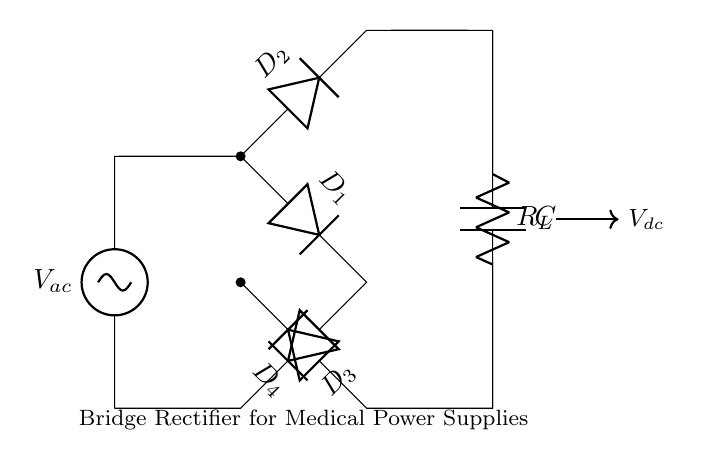What is the input voltage type in this circuit? The input voltage type is alternating current, indicated by the designation "V_ac" in the circuit.
Answer: alternating current How many diodes are used in this bridge rectifier? There are four diodes used in this bridge rectifier, specifically labeled D_1, D_2, D_3, and D_4.
Answer: four What does the capacitor (C) do in this circuit? The capacitor smooths the output voltage by filtering the rectified signal, helping to stabilize the voltage for the load.
Answer: stabilize voltage What is the purpose of the resistor (R_L) in this circuit? The resistor R_L acts as a load to draw current from the output of the rectifier, simulating the device's power demand.
Answer: load What type of circuit is represented here? This is a bridge rectifier circuit, as evidenced by the arrangement of four diodes forming a bridge configuration.
Answer: bridge rectifier What is the output voltage labeled in the circuit? The output voltage is labeled V_dc, which refers to the direct current output generated by the rectifier circuit.
Answer: V_dc 